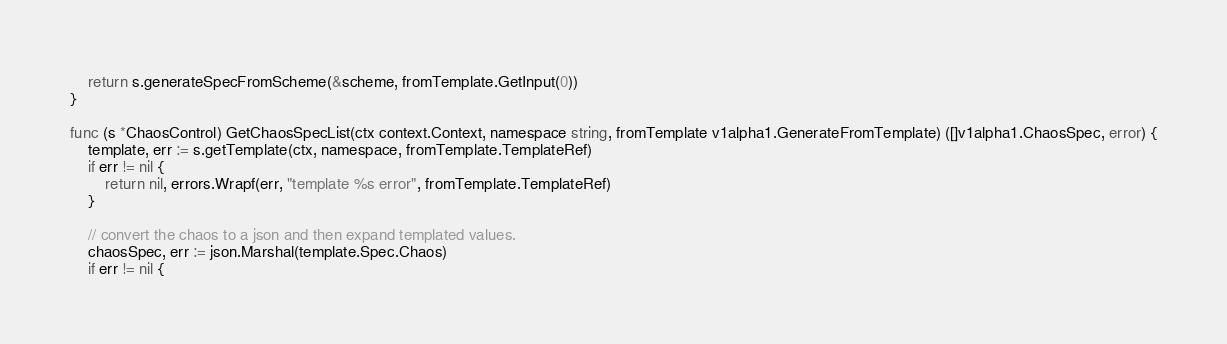<code> <loc_0><loc_0><loc_500><loc_500><_Go_>
	return s.generateSpecFromScheme(&scheme, fromTemplate.GetInput(0))
}

func (s *ChaosControl) GetChaosSpecList(ctx context.Context, namespace string, fromTemplate v1alpha1.GenerateFromTemplate) ([]v1alpha1.ChaosSpec, error) {
	template, err := s.getTemplate(ctx, namespace, fromTemplate.TemplateRef)
	if err != nil {
		return nil, errors.Wrapf(err, "template %s error", fromTemplate.TemplateRef)
	}

	// convert the chaos to a json and then expand templated values.
	chaosSpec, err := json.Marshal(template.Spec.Chaos)
	if err != nil {</code> 